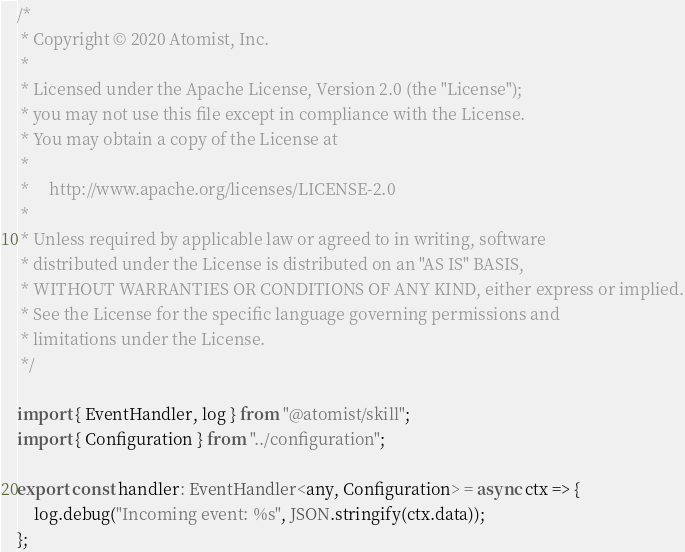Convert code to text. <code><loc_0><loc_0><loc_500><loc_500><_TypeScript_>/*
 * Copyright © 2020 Atomist, Inc.
 *
 * Licensed under the Apache License, Version 2.0 (the "License");
 * you may not use this file except in compliance with the License.
 * You may obtain a copy of the License at
 *
 *     http://www.apache.org/licenses/LICENSE-2.0
 *
 * Unless required by applicable law or agreed to in writing, software
 * distributed under the License is distributed on an "AS IS" BASIS,
 * WITHOUT WARRANTIES OR CONDITIONS OF ANY KIND, either express or implied.
 * See the License for the specific language governing permissions and
 * limitations under the License.
 */

import { EventHandler, log } from "@atomist/skill";
import { Configuration } from "../configuration";

export const handler: EventHandler<any, Configuration> = async ctx => {
	log.debug("Incoming event: %s", JSON.stringify(ctx.data));
};
</code> 